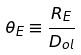<formula> <loc_0><loc_0><loc_500><loc_500>\theta _ { E } \equiv \frac { R _ { E } } { D _ { o l } }</formula> 